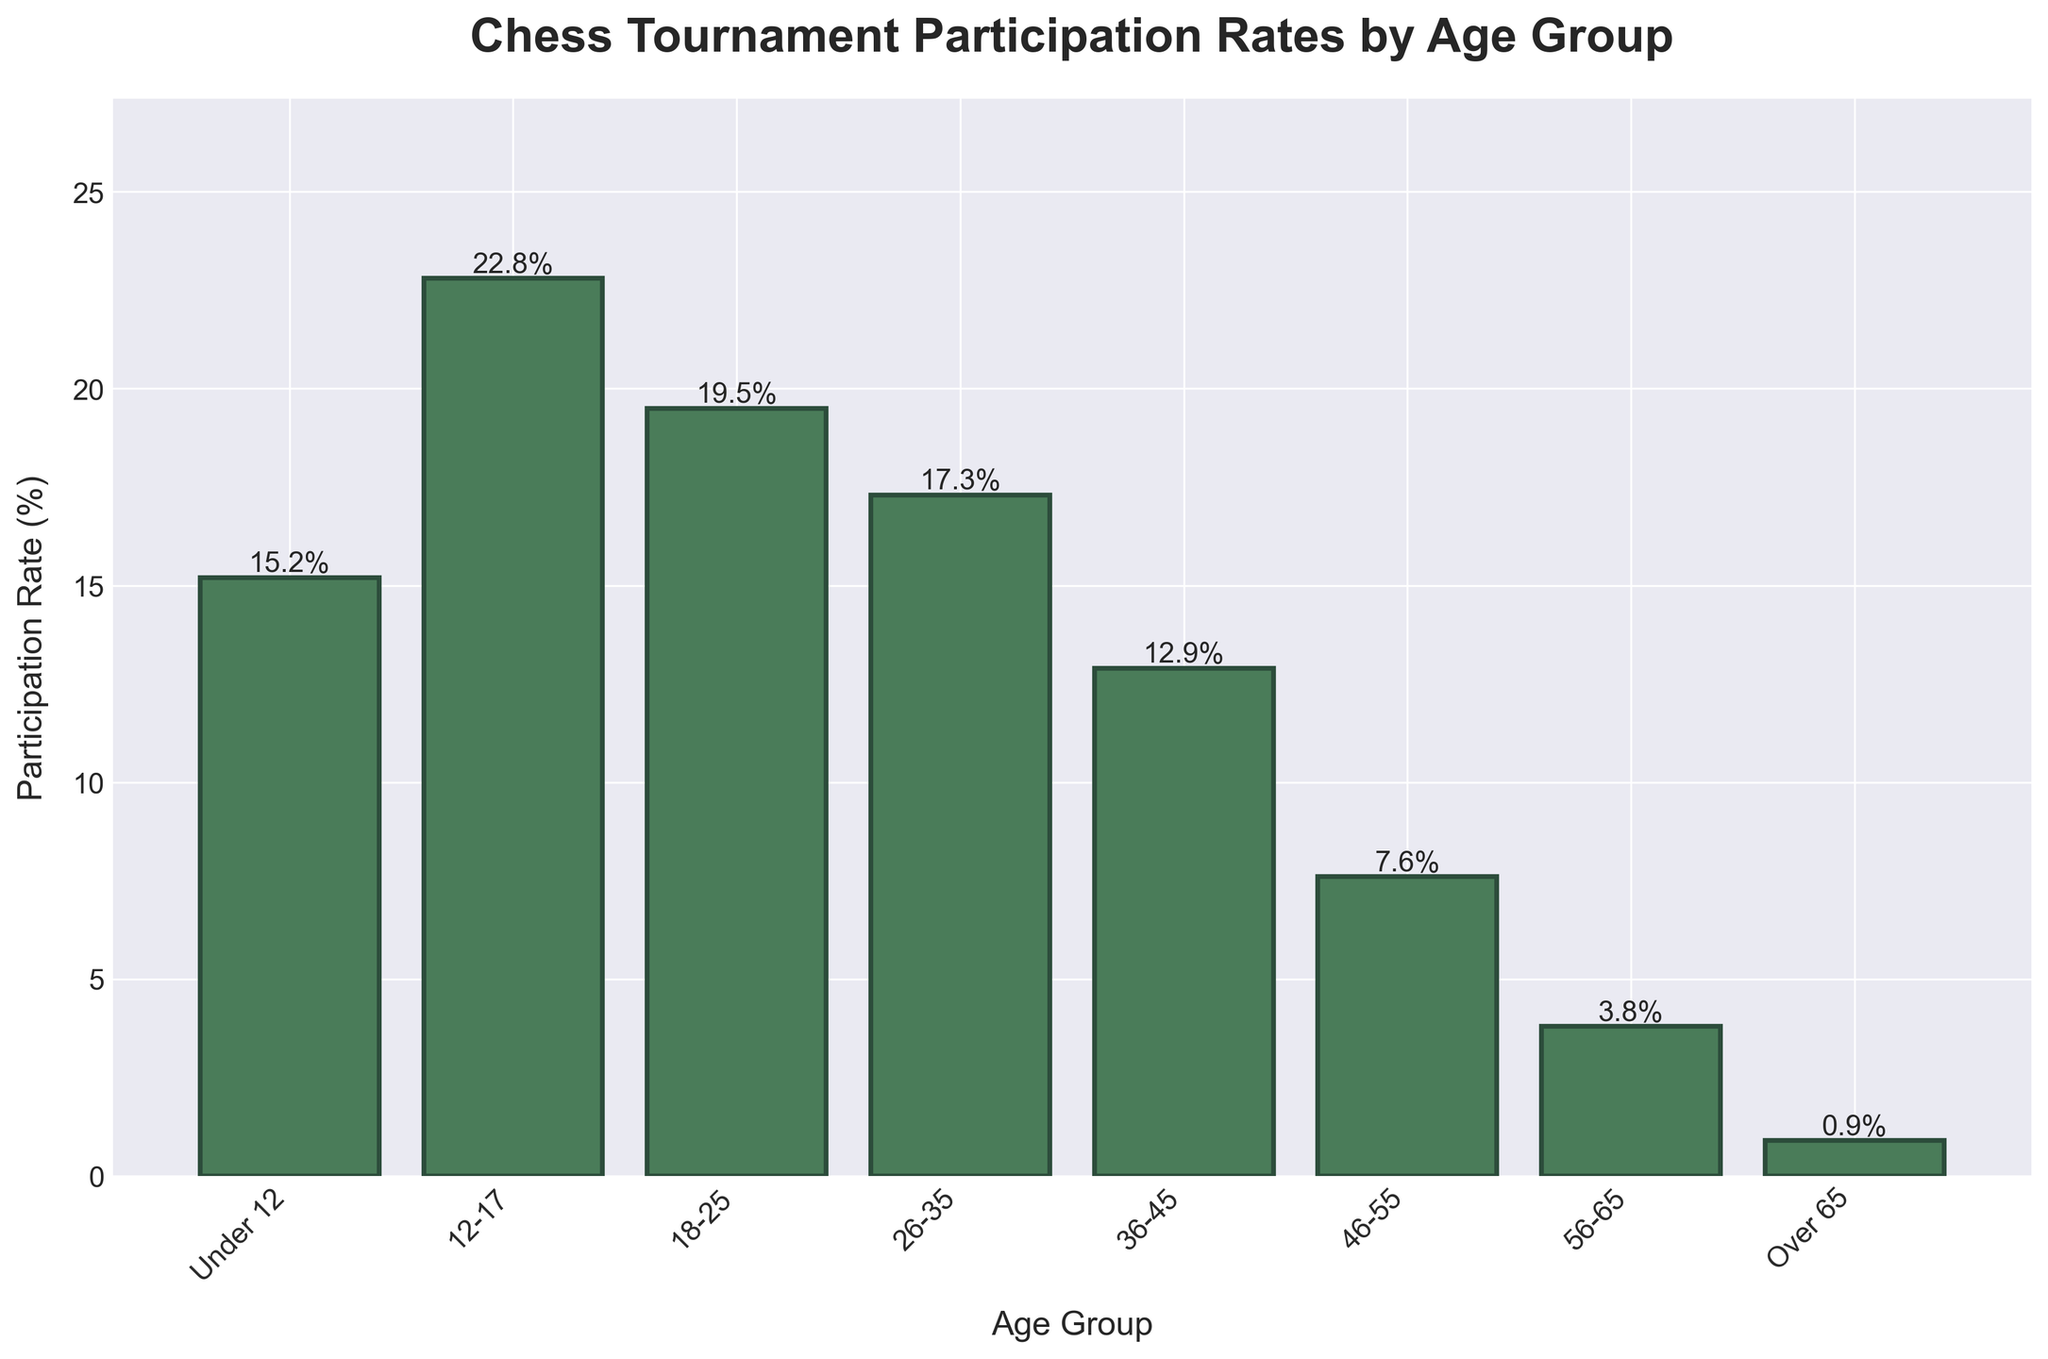What's the age group with the highest participation rate? Identify the tallest bar in the chart and refer to the label on the x-axis.
Answer: 12-17 What is the difference in participation rates between the "18-25" and "26-35" age groups? Read the heights of the bars corresponding to "18-25" (19.5%) and "26-35" (17.3%). Subtract the smaller value from the larger value to find the difference: 19.5% - 17.3% = 2.2%.
Answer: 2.2% Which age groups have participation rates greater than 15%? Identify all bars whose heights exceed the 15% mark. These are "Under 12" (15.2%), "12-17" (22.8%), "18-25" (19.5%), and "26-35" (17.3%).
Answer: Under 12, 12-17, 18-25, 26-35 What is the average participation rate for age groups under 35? Add the participation rates for all age groups under 35: 15.2% (Under 12) + 22.8% (12-17) + 19.5% (18-25) + 17.3% (26-35) = 74.8%. Divide by 4 (the number of groups): 74.8% / 4 = 18.7%.
Answer: 18.7% How much lower is the participation rate for the "Over 65" age group compared to the "36-45" age group? Read the participation rates for "Over 65" (0.9%) and "36-45" (12.9%). Calculate the difference: 12.9% - 0.9% = 12%.
Answer: 12% Which age group has the smallest participation rate, and what is it? Identify the shortest bar in the chart and refer to the label on the x-axis. The smallest participation rate corresponds to the "Over 65" age group with 0.9%.
Answer: Over 65, 0.9% What are the participation rates for age groups with less than 10% participation? Identify bars that are below the 10% mark. These are "46-55" (7.6%), "56-65" (3.8%), and "Over 65" (0.9%).
Answer: 46-55, 56-65, Over 65 How many age groups have a participation rate lower than the "18-25" age group? The participation rate for "18-25" is 19.5%. Identify the number of bars with heights lower than this value. There are five such bars: "Under 12", "26-35", "36-45", "46-55", "56-65", and "Over 65". Count them: 5.
Answer: 5 Which age group has a participation rate closest in value to the "12-17" age group? The participation rate for "12-17" is 22.8%. The closest values are 19.5% (18-25) and 17.3% (26-35). The difference is smaller for "18-25" (3.3% vs. 5.5%), so "18-25" is closest.
Answer: 18-25 